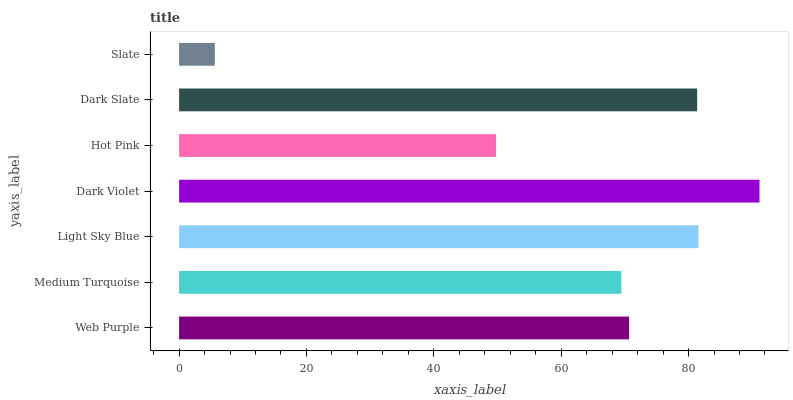Is Slate the minimum?
Answer yes or no. Yes. Is Dark Violet the maximum?
Answer yes or no. Yes. Is Medium Turquoise the minimum?
Answer yes or no. No. Is Medium Turquoise the maximum?
Answer yes or no. No. Is Web Purple greater than Medium Turquoise?
Answer yes or no. Yes. Is Medium Turquoise less than Web Purple?
Answer yes or no. Yes. Is Medium Turquoise greater than Web Purple?
Answer yes or no. No. Is Web Purple less than Medium Turquoise?
Answer yes or no. No. Is Web Purple the high median?
Answer yes or no. Yes. Is Web Purple the low median?
Answer yes or no. Yes. Is Medium Turquoise the high median?
Answer yes or no. No. Is Hot Pink the low median?
Answer yes or no. No. 